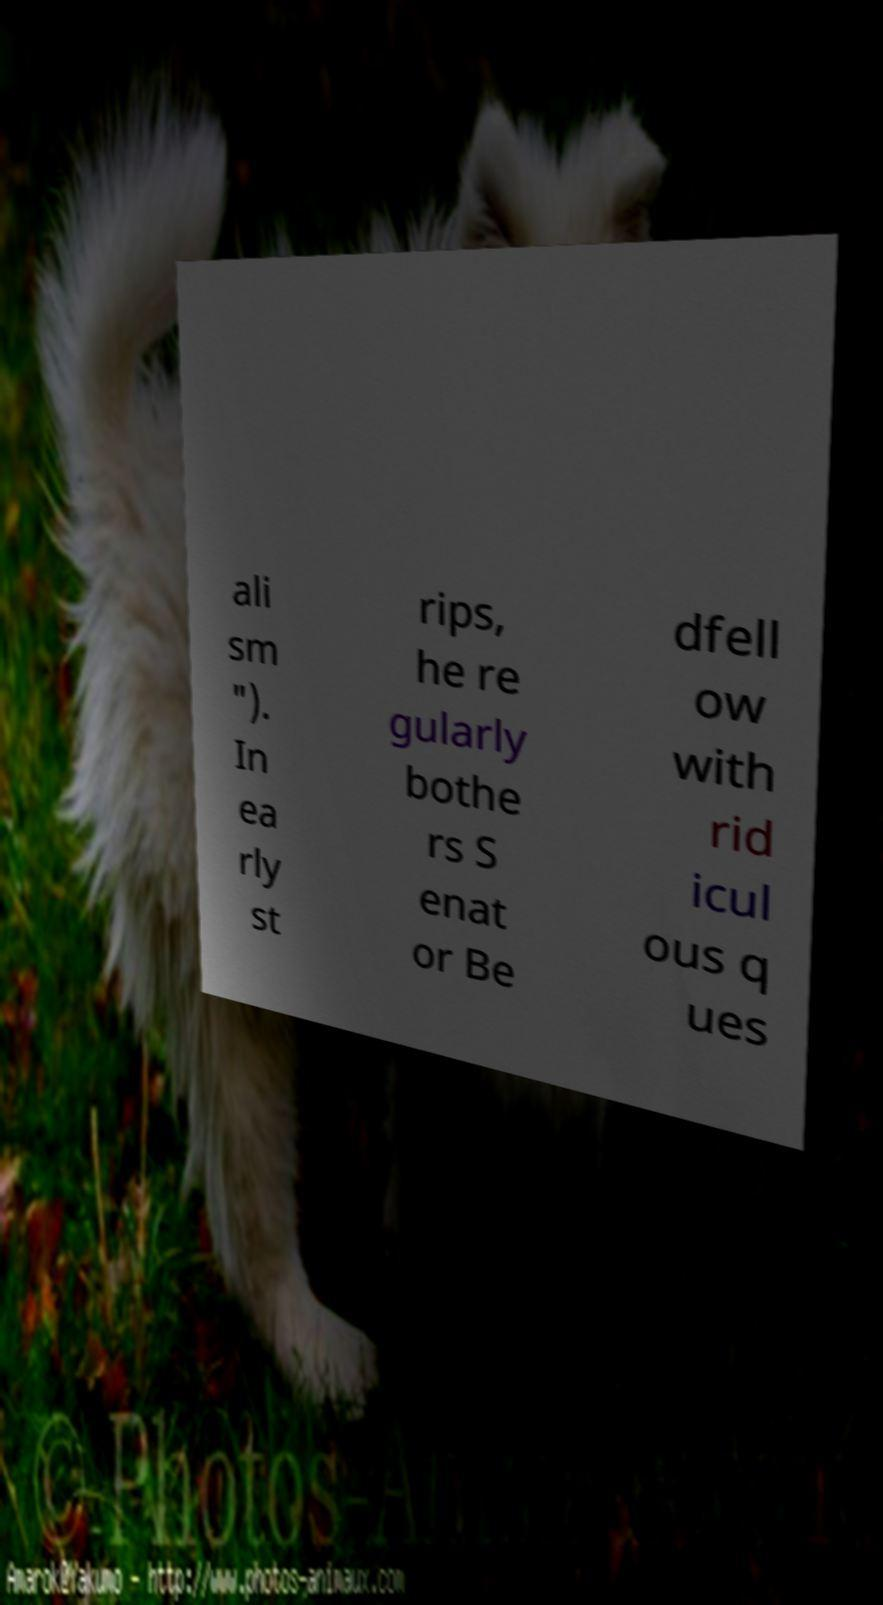Please identify and transcribe the text found in this image. ali sm "). In ea rly st rips, he re gularly bothe rs S enat or Be dfell ow with rid icul ous q ues 